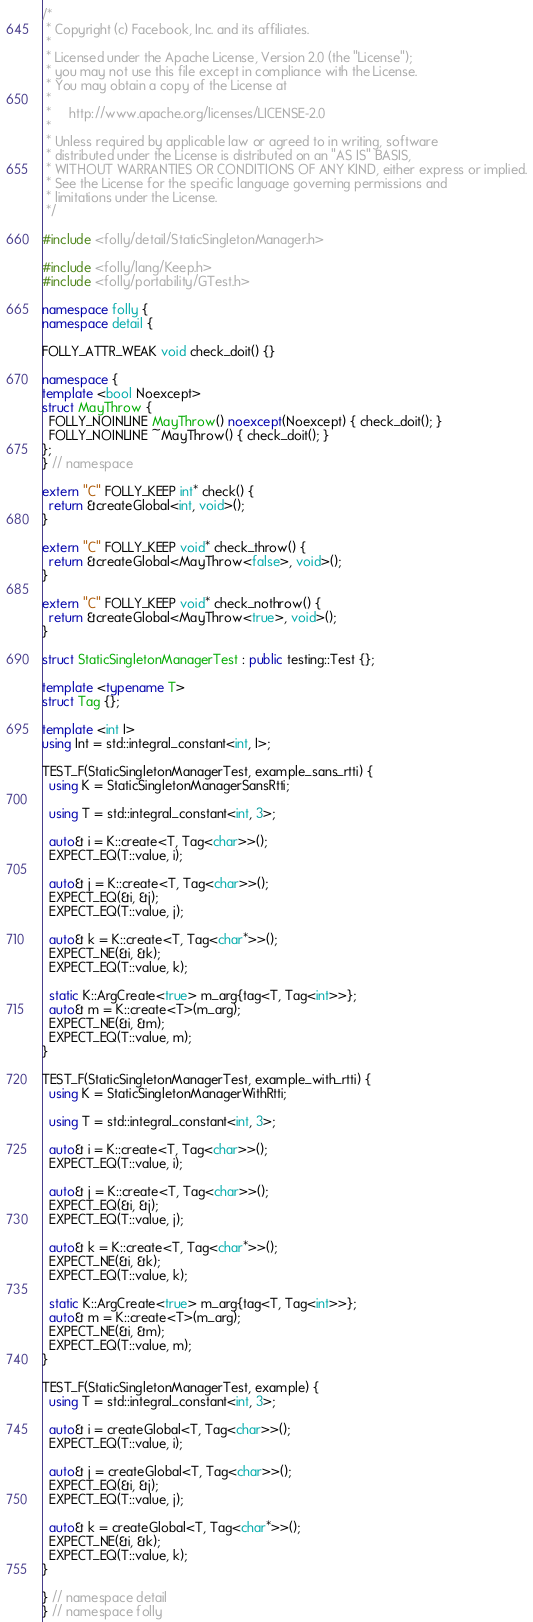Convert code to text. <code><loc_0><loc_0><loc_500><loc_500><_C++_>/*
 * Copyright (c) Facebook, Inc. and its affiliates.
 *
 * Licensed under the Apache License, Version 2.0 (the "License");
 * you may not use this file except in compliance with the License.
 * You may obtain a copy of the License at
 *
 *     http://www.apache.org/licenses/LICENSE-2.0
 *
 * Unless required by applicable law or agreed to in writing, software
 * distributed under the License is distributed on an "AS IS" BASIS,
 * WITHOUT WARRANTIES OR CONDITIONS OF ANY KIND, either express or implied.
 * See the License for the specific language governing permissions and
 * limitations under the License.
 */

#include <folly/detail/StaticSingletonManager.h>

#include <folly/lang/Keep.h>
#include <folly/portability/GTest.h>

namespace folly {
namespace detail {

FOLLY_ATTR_WEAK void check_doit() {}

namespace {
template <bool Noexcept>
struct MayThrow {
  FOLLY_NOINLINE MayThrow() noexcept(Noexcept) { check_doit(); }
  FOLLY_NOINLINE ~MayThrow() { check_doit(); }
};
} // namespace

extern "C" FOLLY_KEEP int* check() {
  return &createGlobal<int, void>();
}

extern "C" FOLLY_KEEP void* check_throw() {
  return &createGlobal<MayThrow<false>, void>();
}

extern "C" FOLLY_KEEP void* check_nothrow() {
  return &createGlobal<MayThrow<true>, void>();
}

struct StaticSingletonManagerTest : public testing::Test {};

template <typename T>
struct Tag {};

template <int I>
using Int = std::integral_constant<int, I>;

TEST_F(StaticSingletonManagerTest, example_sans_rtti) {
  using K = StaticSingletonManagerSansRtti;

  using T = std::integral_constant<int, 3>;

  auto& i = K::create<T, Tag<char>>();
  EXPECT_EQ(T::value, i);

  auto& j = K::create<T, Tag<char>>();
  EXPECT_EQ(&i, &j);
  EXPECT_EQ(T::value, j);

  auto& k = K::create<T, Tag<char*>>();
  EXPECT_NE(&i, &k);
  EXPECT_EQ(T::value, k);

  static K::ArgCreate<true> m_arg{tag<T, Tag<int>>};
  auto& m = K::create<T>(m_arg);
  EXPECT_NE(&i, &m);
  EXPECT_EQ(T::value, m);
}

TEST_F(StaticSingletonManagerTest, example_with_rtti) {
  using K = StaticSingletonManagerWithRtti;

  using T = std::integral_constant<int, 3>;

  auto& i = K::create<T, Tag<char>>();
  EXPECT_EQ(T::value, i);

  auto& j = K::create<T, Tag<char>>();
  EXPECT_EQ(&i, &j);
  EXPECT_EQ(T::value, j);

  auto& k = K::create<T, Tag<char*>>();
  EXPECT_NE(&i, &k);
  EXPECT_EQ(T::value, k);

  static K::ArgCreate<true> m_arg{tag<T, Tag<int>>};
  auto& m = K::create<T>(m_arg);
  EXPECT_NE(&i, &m);
  EXPECT_EQ(T::value, m);
}

TEST_F(StaticSingletonManagerTest, example) {
  using T = std::integral_constant<int, 3>;

  auto& i = createGlobal<T, Tag<char>>();
  EXPECT_EQ(T::value, i);

  auto& j = createGlobal<T, Tag<char>>();
  EXPECT_EQ(&i, &j);
  EXPECT_EQ(T::value, j);

  auto& k = createGlobal<T, Tag<char*>>();
  EXPECT_NE(&i, &k);
  EXPECT_EQ(T::value, k);
}

} // namespace detail
} // namespace folly
</code> 